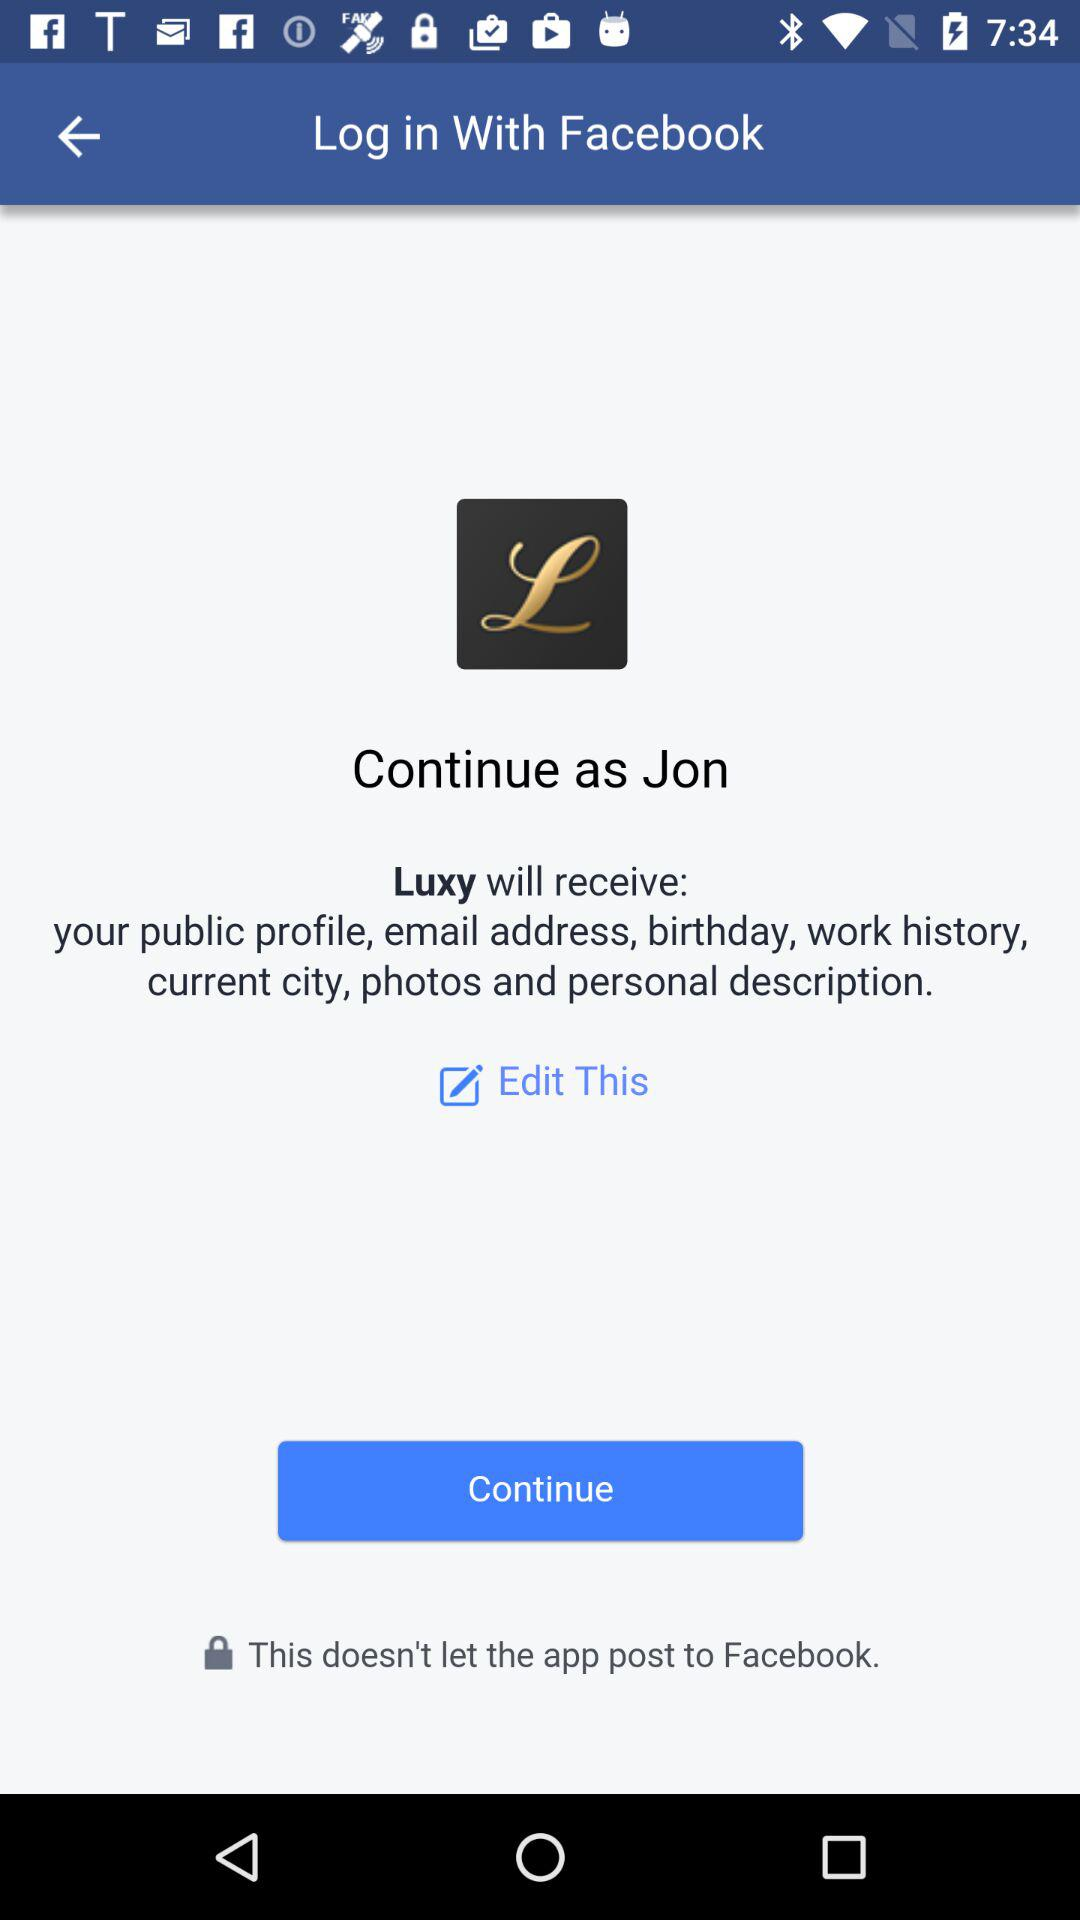What application will receive a public profile, email address, birthday, work history, current city, photos, and personal description? The application that will receive the information is "Luxy". 